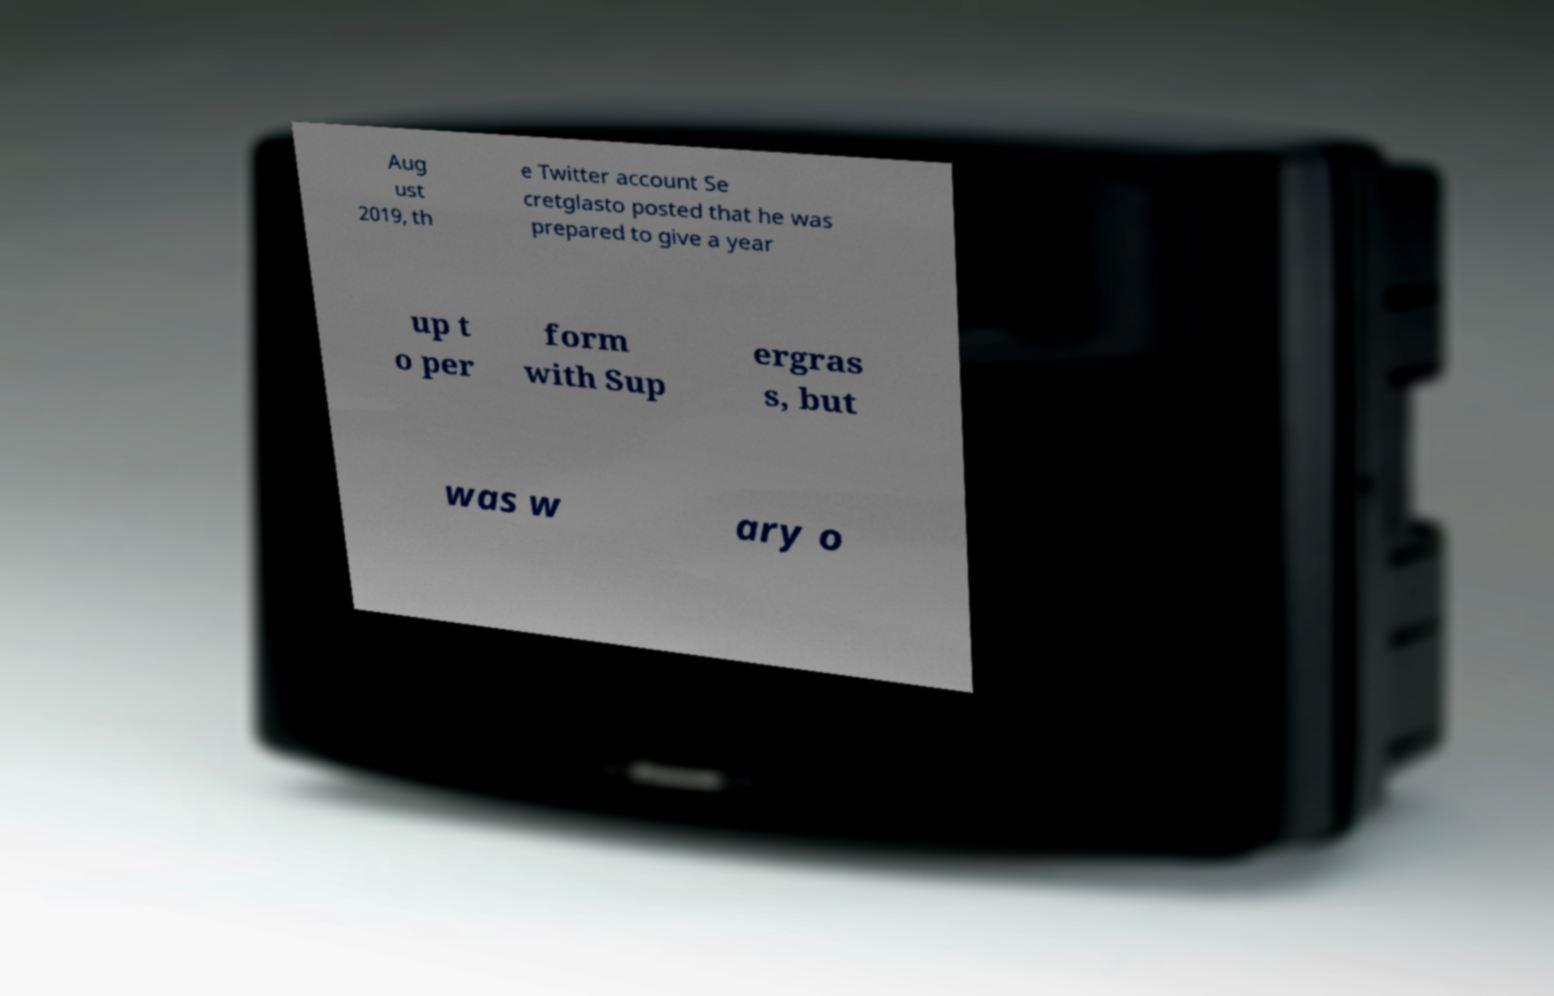Could you assist in decoding the text presented in this image and type it out clearly? Aug ust 2019, th e Twitter account Se cretglasto posted that he was prepared to give a year up t o per form with Sup ergras s, but was w ary o 